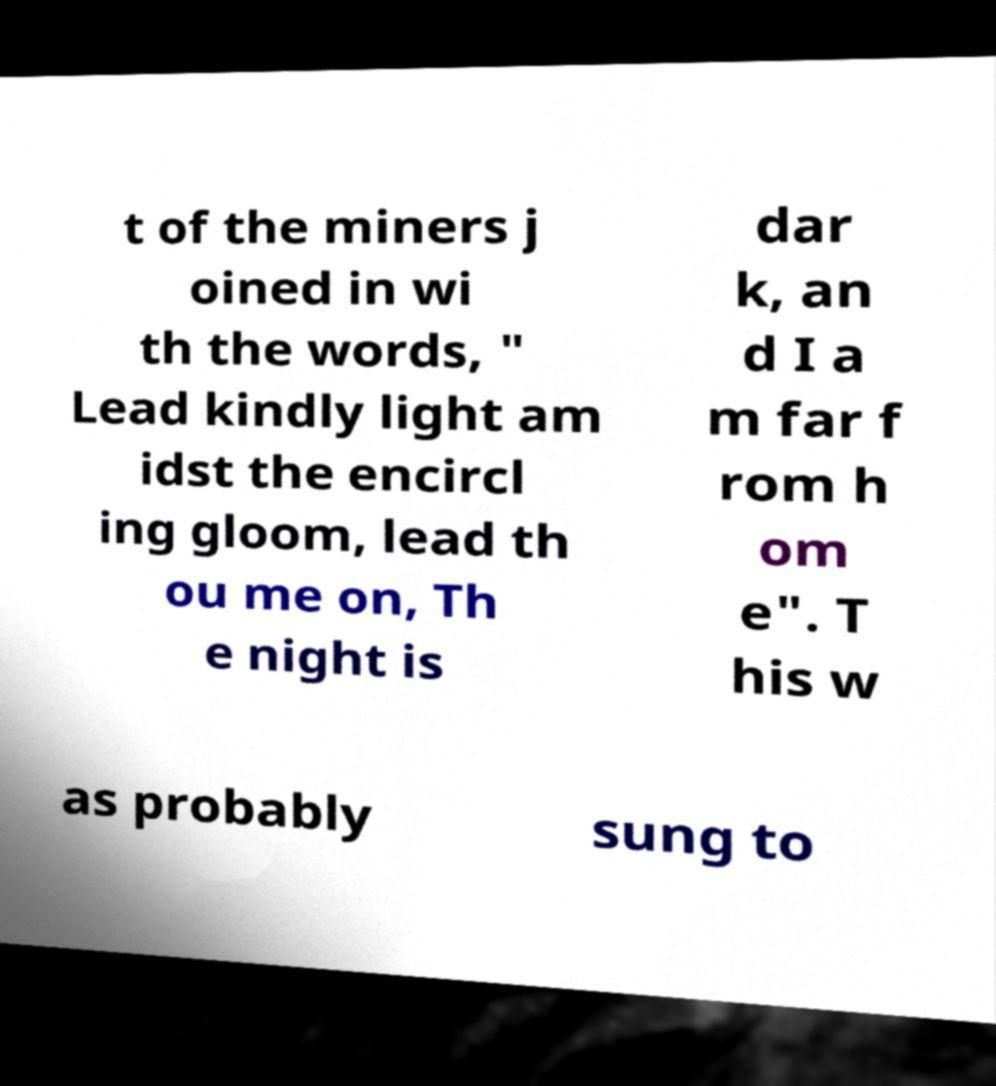Could you assist in decoding the text presented in this image and type it out clearly? t of the miners j oined in wi th the words, " Lead kindly light am idst the encircl ing gloom, lead th ou me on, Th e night is dar k, an d I a m far f rom h om e". T his w as probably sung to 